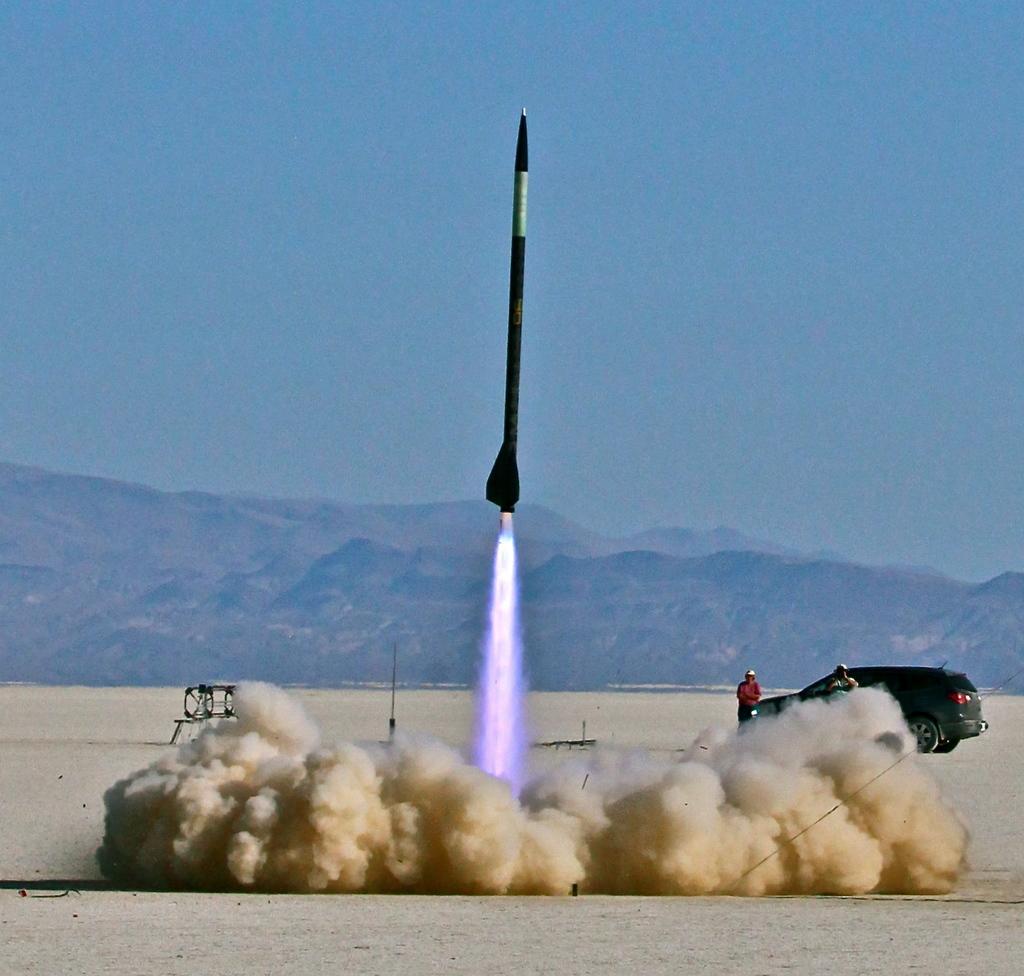Describe this image in one or two sentences. In the picture we can see a rocket flying and leaving a gas and smoke on the sand surface, near to it, we can see a car which is black in color and some persons standing near it and in the background we can see some hills and a sky. 